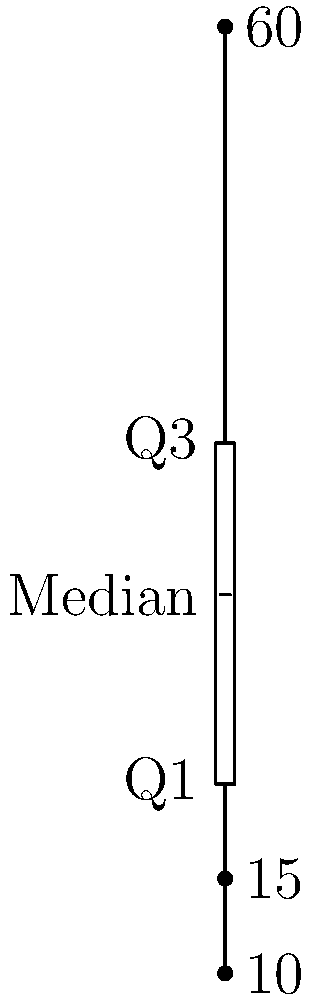As a data scientist familiar with Excel, you're analyzing a dataset using a box plot. Given the box plot above, which data points are considered outliers? To identify outliers using a box plot, we follow these steps:

1. Identify the Interquartile Range (IQR):
   IQR = Q3 - Q1 = 38 - 20 = 18

2. Calculate the lower and upper bounds for outliers:
   Lower bound = Q1 - 1.5 * IQR = 20 - 1.5 * 18 = -7
   Upper bound = Q3 + 1.5 * IQR = 38 + 1.5 * 18 = 65

3. Identify data points outside these bounds:
   Lower bound (-7) < All data points
   60 < Upper bound (65)

4. The whiskers extend to the minimum and maximum values within the bounds.

5. Any points beyond the whiskers are outliers.

In this box plot, we can see three individual points plotted:
- 10 and 15 are within the lower whisker, so they are not outliers.
- 60 is beyond the upper whisker, making it an outlier.

Therefore, the only outlier in this dataset is 60.
Answer: 60 